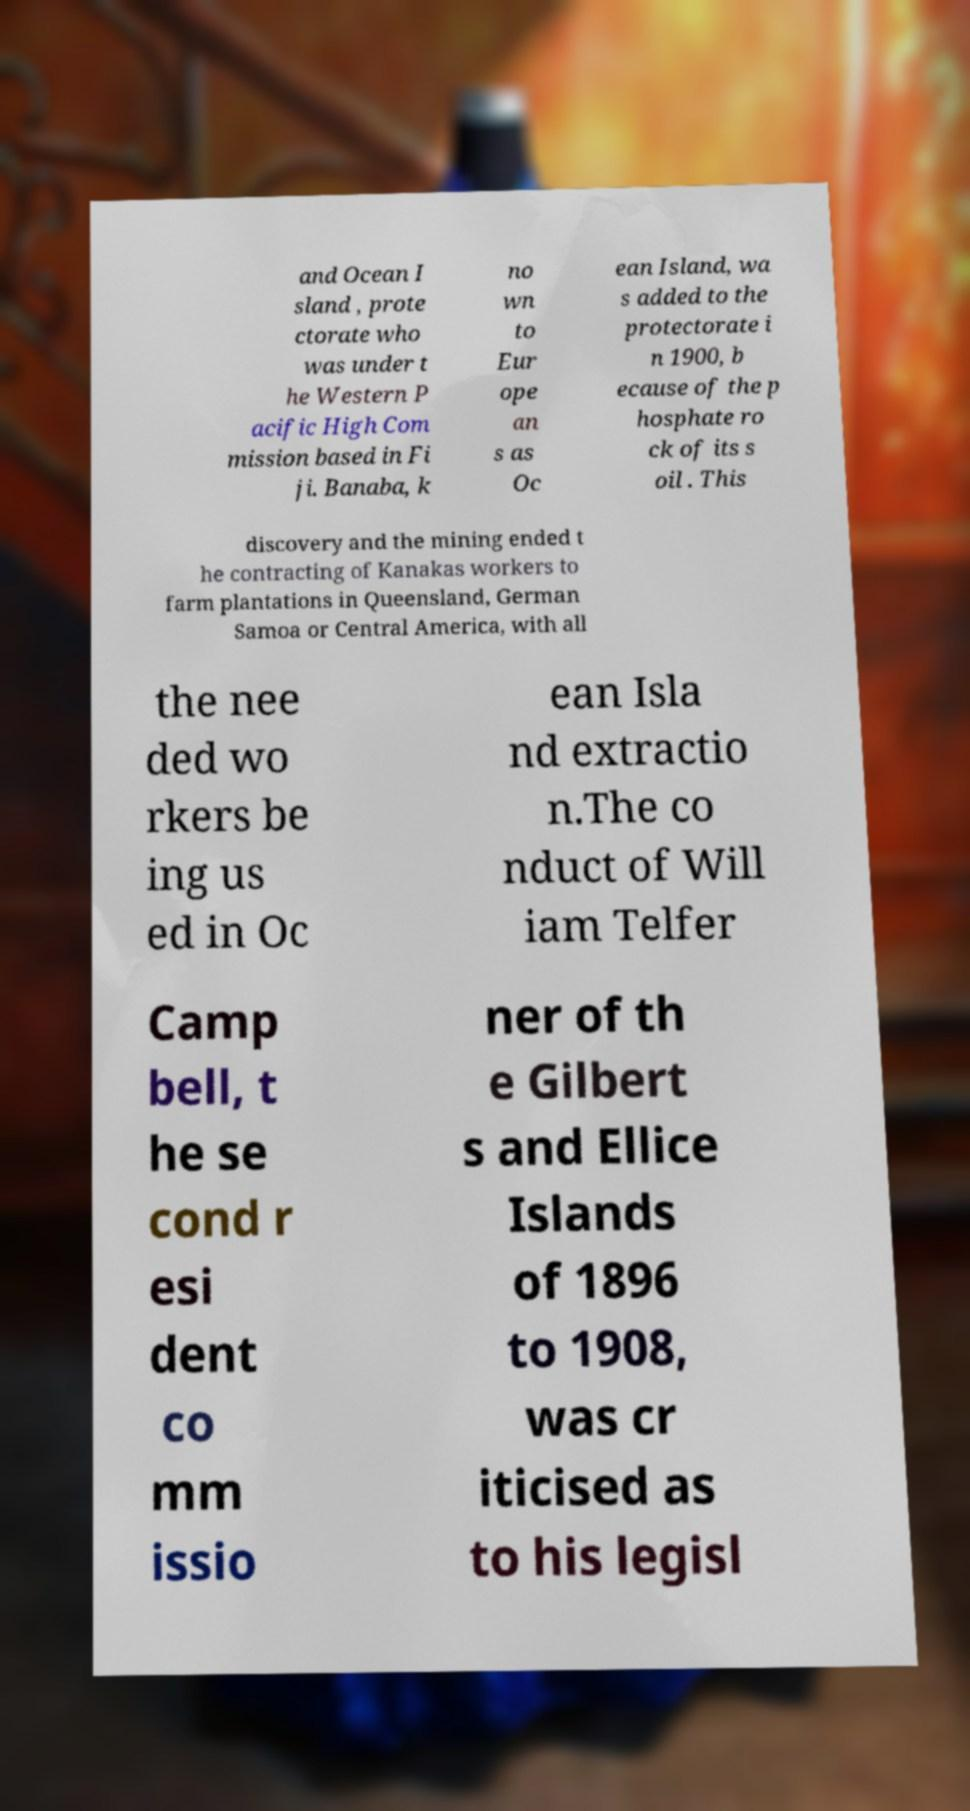Could you extract and type out the text from this image? and Ocean I sland , prote ctorate who was under t he Western P acific High Com mission based in Fi ji. Banaba, k no wn to Eur ope an s as Oc ean Island, wa s added to the protectorate i n 1900, b ecause of the p hosphate ro ck of its s oil . This discovery and the mining ended t he contracting of Kanakas workers to farm plantations in Queensland, German Samoa or Central America, with all the nee ded wo rkers be ing us ed in Oc ean Isla nd extractio n.The co nduct of Will iam Telfer Camp bell, t he se cond r esi dent co mm issio ner of th e Gilbert s and Ellice Islands of 1896 to 1908, was cr iticised as to his legisl 